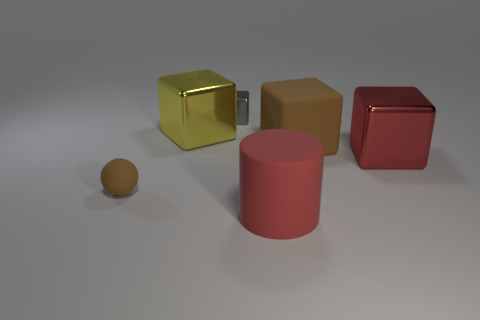Subtract all rubber cubes. How many cubes are left? 3 Subtract all brown cubes. How many cubes are left? 3 Subtract all cylinders. How many objects are left? 5 Subtract 1 cubes. How many cubes are left? 3 Add 4 large brown objects. How many objects exist? 10 Subtract all red balls. How many green blocks are left? 0 Subtract all small yellow metallic spheres. Subtract all yellow metal things. How many objects are left? 5 Add 3 large brown cubes. How many large brown cubes are left? 4 Add 1 purple matte cubes. How many purple matte cubes exist? 1 Subtract 0 blue cubes. How many objects are left? 6 